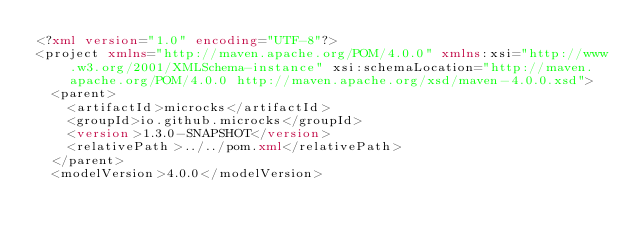<code> <loc_0><loc_0><loc_500><loc_500><_XML_><?xml version="1.0" encoding="UTF-8"?>
<project xmlns="http://maven.apache.org/POM/4.0.0" xmlns:xsi="http://www.w3.org/2001/XMLSchema-instance" xsi:schemaLocation="http://maven.apache.org/POM/4.0.0 http://maven.apache.org/xsd/maven-4.0.0.xsd">
  <parent>
    <artifactId>microcks</artifactId>
    <groupId>io.github.microcks</groupId>
    <version>1.3.0-SNAPSHOT</version>
    <relativePath>../../pom.xml</relativePath>
  </parent>
  <modelVersion>4.0.0</modelVersion>
</code> 